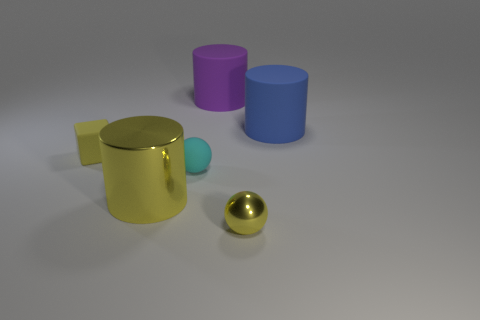There is a big cylinder that is in front of the large thing to the right of the yellow sphere; what color is it?
Ensure brevity in your answer.  Yellow. The big purple object has what shape?
Your response must be concise. Cylinder. Is the size of the rubber thing that is on the right side of the purple matte thing the same as the purple matte cylinder?
Provide a succinct answer. Yes. Are there any yellow cubes that have the same material as the purple cylinder?
Keep it short and to the point. Yes. What number of things are large matte cylinders on the left side of the blue rubber cylinder or large purple rubber cylinders?
Your response must be concise. 1. Are any tiny purple objects visible?
Provide a succinct answer. No. What shape is the yellow object that is right of the small matte cube and behind the yellow shiny sphere?
Offer a terse response. Cylinder. What size is the thing behind the blue matte object?
Make the answer very short. Large. Does the sphere behind the small yellow metallic object have the same color as the big metal cylinder?
Offer a very short reply. No. What number of other tiny yellow metallic objects are the same shape as the small metal object?
Provide a short and direct response. 0. 